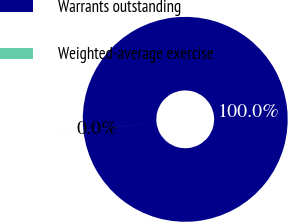Convert chart. <chart><loc_0><loc_0><loc_500><loc_500><pie_chart><fcel>Warrants outstanding<fcel>Weighted-average exercise<nl><fcel>99.99%<fcel>0.01%<nl></chart> 